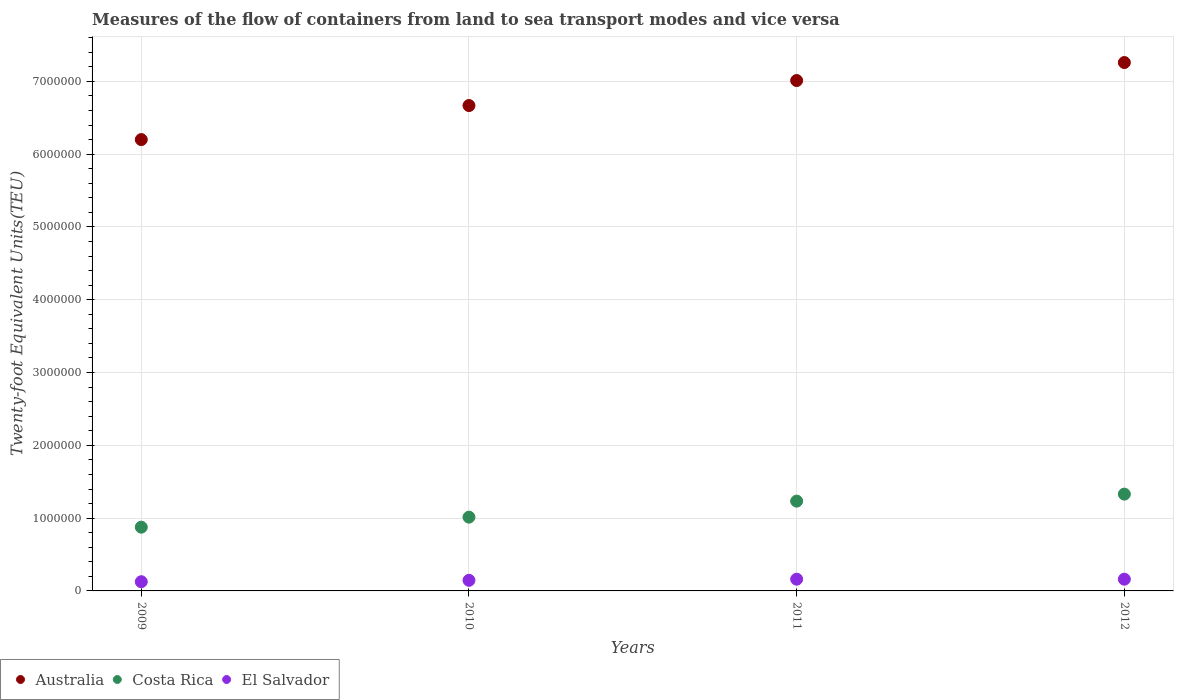Is the number of dotlines equal to the number of legend labels?
Give a very brief answer. Yes. What is the container port traffic in Costa Rica in 2011?
Offer a terse response. 1.23e+06. Across all years, what is the maximum container port traffic in Costa Rica?
Give a very brief answer. 1.33e+06. Across all years, what is the minimum container port traffic in Australia?
Offer a terse response. 6.20e+06. In which year was the container port traffic in El Salvador minimum?
Your answer should be compact. 2009. What is the total container port traffic in Costa Rica in the graph?
Make the answer very short. 4.45e+06. What is the difference between the container port traffic in Australia in 2009 and that in 2010?
Provide a succinct answer. -4.68e+05. What is the difference between the container port traffic in El Salvador in 2011 and the container port traffic in Australia in 2010?
Your response must be concise. -6.51e+06. What is the average container port traffic in Australia per year?
Keep it short and to the point. 6.78e+06. In the year 2011, what is the difference between the container port traffic in El Salvador and container port traffic in Costa Rica?
Offer a terse response. -1.07e+06. In how many years, is the container port traffic in El Salvador greater than 4000000 TEU?
Provide a succinct answer. 0. What is the ratio of the container port traffic in El Salvador in 2009 to that in 2011?
Make the answer very short. 0.78. Is the container port traffic in Costa Rica in 2009 less than that in 2012?
Keep it short and to the point. Yes. Is the difference between the container port traffic in El Salvador in 2010 and 2011 greater than the difference between the container port traffic in Costa Rica in 2010 and 2011?
Your answer should be compact. Yes. What is the difference between the highest and the second highest container port traffic in El Salvador?
Provide a succinct answer. 200. What is the difference between the highest and the lowest container port traffic in Costa Rica?
Offer a very short reply. 4.54e+05. Is it the case that in every year, the sum of the container port traffic in Australia and container port traffic in El Salvador  is greater than the container port traffic in Costa Rica?
Give a very brief answer. Yes. Does the container port traffic in Australia monotonically increase over the years?
Offer a very short reply. Yes. Is the container port traffic in El Salvador strictly less than the container port traffic in Australia over the years?
Offer a very short reply. Yes. What is the difference between two consecutive major ticks on the Y-axis?
Your answer should be compact. 1.00e+06. Are the values on the major ticks of Y-axis written in scientific E-notation?
Offer a very short reply. No. Does the graph contain any zero values?
Your response must be concise. No. Does the graph contain grids?
Offer a terse response. Yes. Where does the legend appear in the graph?
Your answer should be very brief. Bottom left. How many legend labels are there?
Your answer should be very brief. 3. What is the title of the graph?
Your answer should be compact. Measures of the flow of containers from land to sea transport modes and vice versa. Does "Cuba" appear as one of the legend labels in the graph?
Provide a short and direct response. No. What is the label or title of the X-axis?
Your response must be concise. Years. What is the label or title of the Y-axis?
Give a very brief answer. Twenty-foot Equivalent Units(TEU). What is the Twenty-foot Equivalent Units(TEU) in Australia in 2009?
Give a very brief answer. 6.20e+06. What is the Twenty-foot Equivalent Units(TEU) of Costa Rica in 2009?
Offer a very short reply. 8.76e+05. What is the Twenty-foot Equivalent Units(TEU) in El Salvador in 2009?
Your answer should be very brief. 1.26e+05. What is the Twenty-foot Equivalent Units(TEU) of Australia in 2010?
Your response must be concise. 6.67e+06. What is the Twenty-foot Equivalent Units(TEU) of Costa Rica in 2010?
Keep it short and to the point. 1.01e+06. What is the Twenty-foot Equivalent Units(TEU) in El Salvador in 2010?
Offer a very short reply. 1.46e+05. What is the Twenty-foot Equivalent Units(TEU) in Australia in 2011?
Offer a very short reply. 7.01e+06. What is the Twenty-foot Equivalent Units(TEU) in Costa Rica in 2011?
Make the answer very short. 1.23e+06. What is the Twenty-foot Equivalent Units(TEU) in El Salvador in 2011?
Provide a short and direct response. 1.61e+05. What is the Twenty-foot Equivalent Units(TEU) in Australia in 2012?
Make the answer very short. 7.26e+06. What is the Twenty-foot Equivalent Units(TEU) of Costa Rica in 2012?
Give a very brief answer. 1.33e+06. What is the Twenty-foot Equivalent Units(TEU) of El Salvador in 2012?
Offer a very short reply. 1.61e+05. Across all years, what is the maximum Twenty-foot Equivalent Units(TEU) of Australia?
Give a very brief answer. 7.26e+06. Across all years, what is the maximum Twenty-foot Equivalent Units(TEU) of Costa Rica?
Provide a succinct answer. 1.33e+06. Across all years, what is the maximum Twenty-foot Equivalent Units(TEU) in El Salvador?
Your answer should be very brief. 1.61e+05. Across all years, what is the minimum Twenty-foot Equivalent Units(TEU) in Australia?
Your answer should be compact. 6.20e+06. Across all years, what is the minimum Twenty-foot Equivalent Units(TEU) in Costa Rica?
Your answer should be compact. 8.76e+05. Across all years, what is the minimum Twenty-foot Equivalent Units(TEU) in El Salvador?
Your answer should be very brief. 1.26e+05. What is the total Twenty-foot Equivalent Units(TEU) in Australia in the graph?
Your answer should be very brief. 2.71e+07. What is the total Twenty-foot Equivalent Units(TEU) in Costa Rica in the graph?
Your answer should be compact. 4.45e+06. What is the total Twenty-foot Equivalent Units(TEU) in El Salvador in the graph?
Provide a succinct answer. 5.94e+05. What is the difference between the Twenty-foot Equivalent Units(TEU) of Australia in 2009 and that in 2010?
Offer a very short reply. -4.68e+05. What is the difference between the Twenty-foot Equivalent Units(TEU) of Costa Rica in 2009 and that in 2010?
Your answer should be very brief. -1.38e+05. What is the difference between the Twenty-foot Equivalent Units(TEU) of El Salvador in 2009 and that in 2010?
Offer a very short reply. -1.94e+04. What is the difference between the Twenty-foot Equivalent Units(TEU) of Australia in 2009 and that in 2011?
Ensure brevity in your answer.  -8.11e+05. What is the difference between the Twenty-foot Equivalent Units(TEU) of Costa Rica in 2009 and that in 2011?
Give a very brief answer. -3.58e+05. What is the difference between the Twenty-foot Equivalent Units(TEU) of El Salvador in 2009 and that in 2011?
Offer a very short reply. -3.48e+04. What is the difference between the Twenty-foot Equivalent Units(TEU) in Australia in 2009 and that in 2012?
Provide a succinct answer. -1.06e+06. What is the difference between the Twenty-foot Equivalent Units(TEU) of Costa Rica in 2009 and that in 2012?
Offer a very short reply. -4.54e+05. What is the difference between the Twenty-foot Equivalent Units(TEU) of El Salvador in 2009 and that in 2012?
Ensure brevity in your answer.  -3.46e+04. What is the difference between the Twenty-foot Equivalent Units(TEU) of Australia in 2010 and that in 2011?
Make the answer very short. -3.44e+05. What is the difference between the Twenty-foot Equivalent Units(TEU) in Costa Rica in 2010 and that in 2011?
Your answer should be compact. -2.20e+05. What is the difference between the Twenty-foot Equivalent Units(TEU) of El Salvador in 2010 and that in 2011?
Ensure brevity in your answer.  -1.54e+04. What is the difference between the Twenty-foot Equivalent Units(TEU) in Australia in 2010 and that in 2012?
Offer a very short reply. -5.91e+05. What is the difference between the Twenty-foot Equivalent Units(TEU) of Costa Rica in 2010 and that in 2012?
Ensure brevity in your answer.  -3.16e+05. What is the difference between the Twenty-foot Equivalent Units(TEU) of El Salvador in 2010 and that in 2012?
Ensure brevity in your answer.  -1.52e+04. What is the difference between the Twenty-foot Equivalent Units(TEU) in Australia in 2011 and that in 2012?
Your answer should be very brief. -2.47e+05. What is the difference between the Twenty-foot Equivalent Units(TEU) in Costa Rica in 2011 and that in 2012?
Your answer should be compact. -9.62e+04. What is the difference between the Twenty-foot Equivalent Units(TEU) in Australia in 2009 and the Twenty-foot Equivalent Units(TEU) in Costa Rica in 2010?
Offer a very short reply. 5.19e+06. What is the difference between the Twenty-foot Equivalent Units(TEU) in Australia in 2009 and the Twenty-foot Equivalent Units(TEU) in El Salvador in 2010?
Make the answer very short. 6.05e+06. What is the difference between the Twenty-foot Equivalent Units(TEU) of Costa Rica in 2009 and the Twenty-foot Equivalent Units(TEU) of El Salvador in 2010?
Your answer should be compact. 7.30e+05. What is the difference between the Twenty-foot Equivalent Units(TEU) in Australia in 2009 and the Twenty-foot Equivalent Units(TEU) in Costa Rica in 2011?
Your answer should be very brief. 4.97e+06. What is the difference between the Twenty-foot Equivalent Units(TEU) in Australia in 2009 and the Twenty-foot Equivalent Units(TEU) in El Salvador in 2011?
Your answer should be very brief. 6.04e+06. What is the difference between the Twenty-foot Equivalent Units(TEU) of Costa Rica in 2009 and the Twenty-foot Equivalent Units(TEU) of El Salvador in 2011?
Provide a short and direct response. 7.14e+05. What is the difference between the Twenty-foot Equivalent Units(TEU) in Australia in 2009 and the Twenty-foot Equivalent Units(TEU) in Costa Rica in 2012?
Keep it short and to the point. 4.87e+06. What is the difference between the Twenty-foot Equivalent Units(TEU) in Australia in 2009 and the Twenty-foot Equivalent Units(TEU) in El Salvador in 2012?
Make the answer very short. 6.04e+06. What is the difference between the Twenty-foot Equivalent Units(TEU) in Costa Rica in 2009 and the Twenty-foot Equivalent Units(TEU) in El Salvador in 2012?
Provide a short and direct response. 7.15e+05. What is the difference between the Twenty-foot Equivalent Units(TEU) in Australia in 2010 and the Twenty-foot Equivalent Units(TEU) in Costa Rica in 2011?
Offer a terse response. 5.43e+06. What is the difference between the Twenty-foot Equivalent Units(TEU) in Australia in 2010 and the Twenty-foot Equivalent Units(TEU) in El Salvador in 2011?
Your response must be concise. 6.51e+06. What is the difference between the Twenty-foot Equivalent Units(TEU) in Costa Rica in 2010 and the Twenty-foot Equivalent Units(TEU) in El Salvador in 2011?
Your response must be concise. 8.52e+05. What is the difference between the Twenty-foot Equivalent Units(TEU) of Australia in 2010 and the Twenty-foot Equivalent Units(TEU) of Costa Rica in 2012?
Provide a short and direct response. 5.34e+06. What is the difference between the Twenty-foot Equivalent Units(TEU) of Australia in 2010 and the Twenty-foot Equivalent Units(TEU) of El Salvador in 2012?
Provide a succinct answer. 6.51e+06. What is the difference between the Twenty-foot Equivalent Units(TEU) in Costa Rica in 2010 and the Twenty-foot Equivalent Units(TEU) in El Salvador in 2012?
Ensure brevity in your answer.  8.52e+05. What is the difference between the Twenty-foot Equivalent Units(TEU) of Australia in 2011 and the Twenty-foot Equivalent Units(TEU) of Costa Rica in 2012?
Provide a short and direct response. 5.68e+06. What is the difference between the Twenty-foot Equivalent Units(TEU) of Australia in 2011 and the Twenty-foot Equivalent Units(TEU) of El Salvador in 2012?
Keep it short and to the point. 6.85e+06. What is the difference between the Twenty-foot Equivalent Units(TEU) of Costa Rica in 2011 and the Twenty-foot Equivalent Units(TEU) of El Salvador in 2012?
Offer a terse response. 1.07e+06. What is the average Twenty-foot Equivalent Units(TEU) in Australia per year?
Your answer should be compact. 6.78e+06. What is the average Twenty-foot Equivalent Units(TEU) in Costa Rica per year?
Your answer should be compact. 1.11e+06. What is the average Twenty-foot Equivalent Units(TEU) in El Salvador per year?
Your response must be concise. 1.49e+05. In the year 2009, what is the difference between the Twenty-foot Equivalent Units(TEU) of Australia and Twenty-foot Equivalent Units(TEU) of Costa Rica?
Your answer should be very brief. 5.32e+06. In the year 2009, what is the difference between the Twenty-foot Equivalent Units(TEU) in Australia and Twenty-foot Equivalent Units(TEU) in El Salvador?
Offer a very short reply. 6.07e+06. In the year 2009, what is the difference between the Twenty-foot Equivalent Units(TEU) of Costa Rica and Twenty-foot Equivalent Units(TEU) of El Salvador?
Provide a succinct answer. 7.49e+05. In the year 2010, what is the difference between the Twenty-foot Equivalent Units(TEU) of Australia and Twenty-foot Equivalent Units(TEU) of Costa Rica?
Your answer should be compact. 5.65e+06. In the year 2010, what is the difference between the Twenty-foot Equivalent Units(TEU) in Australia and Twenty-foot Equivalent Units(TEU) in El Salvador?
Offer a very short reply. 6.52e+06. In the year 2010, what is the difference between the Twenty-foot Equivalent Units(TEU) in Costa Rica and Twenty-foot Equivalent Units(TEU) in El Salvador?
Provide a short and direct response. 8.68e+05. In the year 2011, what is the difference between the Twenty-foot Equivalent Units(TEU) in Australia and Twenty-foot Equivalent Units(TEU) in Costa Rica?
Your answer should be compact. 5.78e+06. In the year 2011, what is the difference between the Twenty-foot Equivalent Units(TEU) of Australia and Twenty-foot Equivalent Units(TEU) of El Salvador?
Keep it short and to the point. 6.85e+06. In the year 2011, what is the difference between the Twenty-foot Equivalent Units(TEU) in Costa Rica and Twenty-foot Equivalent Units(TEU) in El Salvador?
Offer a very short reply. 1.07e+06. In the year 2012, what is the difference between the Twenty-foot Equivalent Units(TEU) in Australia and Twenty-foot Equivalent Units(TEU) in Costa Rica?
Your answer should be compact. 5.93e+06. In the year 2012, what is the difference between the Twenty-foot Equivalent Units(TEU) of Australia and Twenty-foot Equivalent Units(TEU) of El Salvador?
Provide a short and direct response. 7.10e+06. In the year 2012, what is the difference between the Twenty-foot Equivalent Units(TEU) in Costa Rica and Twenty-foot Equivalent Units(TEU) in El Salvador?
Offer a very short reply. 1.17e+06. What is the ratio of the Twenty-foot Equivalent Units(TEU) of Australia in 2009 to that in 2010?
Your answer should be compact. 0.93. What is the ratio of the Twenty-foot Equivalent Units(TEU) of Costa Rica in 2009 to that in 2010?
Your answer should be very brief. 0.86. What is the ratio of the Twenty-foot Equivalent Units(TEU) in El Salvador in 2009 to that in 2010?
Provide a short and direct response. 0.87. What is the ratio of the Twenty-foot Equivalent Units(TEU) of Australia in 2009 to that in 2011?
Provide a short and direct response. 0.88. What is the ratio of the Twenty-foot Equivalent Units(TEU) of Costa Rica in 2009 to that in 2011?
Your answer should be compact. 0.71. What is the ratio of the Twenty-foot Equivalent Units(TEU) in El Salvador in 2009 to that in 2011?
Offer a terse response. 0.78. What is the ratio of the Twenty-foot Equivalent Units(TEU) in Australia in 2009 to that in 2012?
Provide a succinct answer. 0.85. What is the ratio of the Twenty-foot Equivalent Units(TEU) of Costa Rica in 2009 to that in 2012?
Ensure brevity in your answer.  0.66. What is the ratio of the Twenty-foot Equivalent Units(TEU) of El Salvador in 2009 to that in 2012?
Provide a succinct answer. 0.78. What is the ratio of the Twenty-foot Equivalent Units(TEU) in Australia in 2010 to that in 2011?
Give a very brief answer. 0.95. What is the ratio of the Twenty-foot Equivalent Units(TEU) in Costa Rica in 2010 to that in 2011?
Keep it short and to the point. 0.82. What is the ratio of the Twenty-foot Equivalent Units(TEU) in El Salvador in 2010 to that in 2011?
Offer a very short reply. 0.9. What is the ratio of the Twenty-foot Equivalent Units(TEU) of Australia in 2010 to that in 2012?
Offer a very short reply. 0.92. What is the ratio of the Twenty-foot Equivalent Units(TEU) of Costa Rica in 2010 to that in 2012?
Offer a very short reply. 0.76. What is the ratio of the Twenty-foot Equivalent Units(TEU) in El Salvador in 2010 to that in 2012?
Offer a very short reply. 0.91. What is the ratio of the Twenty-foot Equivalent Units(TEU) of Australia in 2011 to that in 2012?
Provide a succinct answer. 0.97. What is the ratio of the Twenty-foot Equivalent Units(TEU) of Costa Rica in 2011 to that in 2012?
Your answer should be very brief. 0.93. What is the difference between the highest and the second highest Twenty-foot Equivalent Units(TEU) of Australia?
Your answer should be compact. 2.47e+05. What is the difference between the highest and the second highest Twenty-foot Equivalent Units(TEU) in Costa Rica?
Your answer should be very brief. 9.62e+04. What is the difference between the highest and the lowest Twenty-foot Equivalent Units(TEU) of Australia?
Provide a short and direct response. 1.06e+06. What is the difference between the highest and the lowest Twenty-foot Equivalent Units(TEU) in Costa Rica?
Give a very brief answer. 4.54e+05. What is the difference between the highest and the lowest Twenty-foot Equivalent Units(TEU) of El Salvador?
Give a very brief answer. 3.48e+04. 